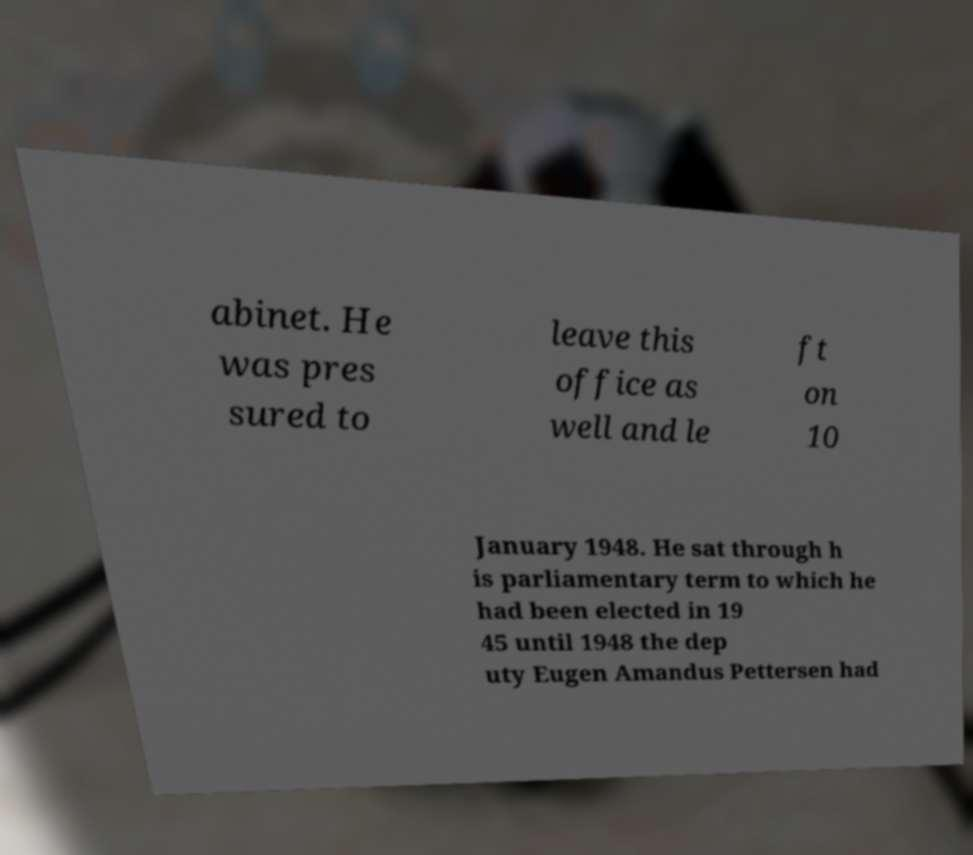What messages or text are displayed in this image? I need them in a readable, typed format. abinet. He was pres sured to leave this office as well and le ft on 10 January 1948. He sat through h is parliamentary term to which he had been elected in 19 45 until 1948 the dep uty Eugen Amandus Pettersen had 